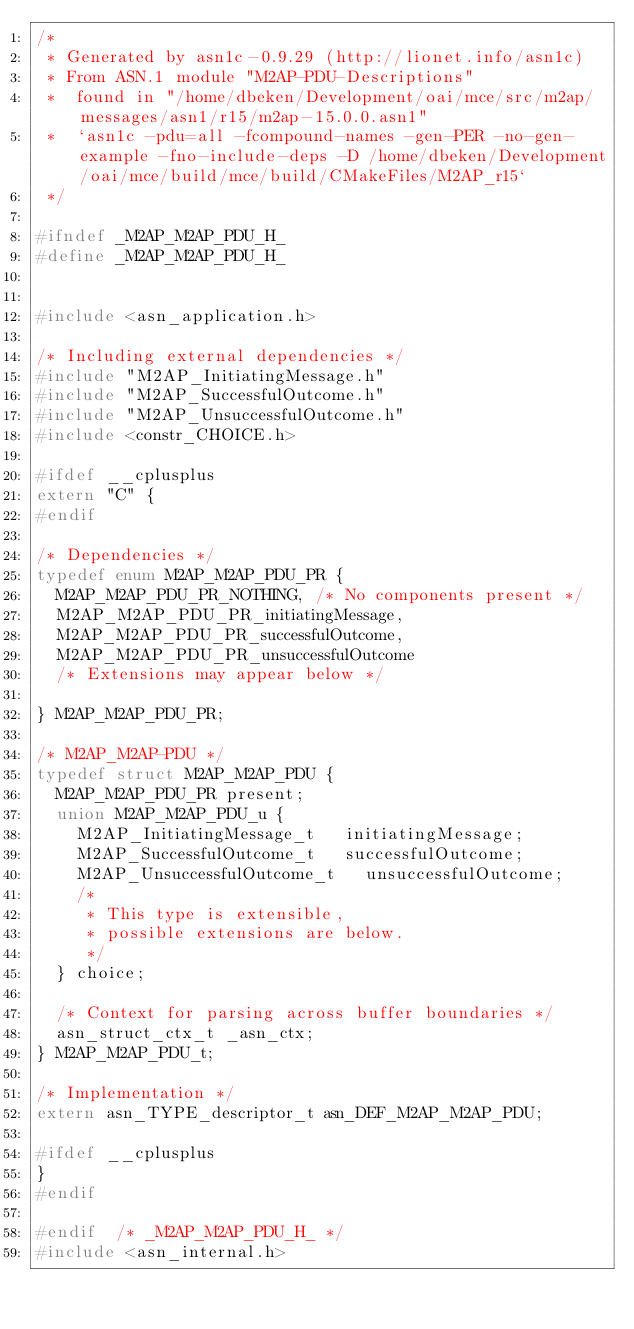Convert code to text. <code><loc_0><loc_0><loc_500><loc_500><_C_>/*
 * Generated by asn1c-0.9.29 (http://lionet.info/asn1c)
 * From ASN.1 module "M2AP-PDU-Descriptions"
 * 	found in "/home/dbeken/Development/oai/mce/src/m2ap/messages/asn1/r15/m2ap-15.0.0.asn1"
 * 	`asn1c -pdu=all -fcompound-names -gen-PER -no-gen-example -fno-include-deps -D /home/dbeken/Development/oai/mce/build/mce/build/CMakeFiles/M2AP_r15`
 */

#ifndef	_M2AP_M2AP_PDU_H_
#define	_M2AP_M2AP_PDU_H_


#include <asn_application.h>

/* Including external dependencies */
#include "M2AP_InitiatingMessage.h"
#include "M2AP_SuccessfulOutcome.h"
#include "M2AP_UnsuccessfulOutcome.h"
#include <constr_CHOICE.h>

#ifdef __cplusplus
extern "C" {
#endif

/* Dependencies */
typedef enum M2AP_M2AP_PDU_PR {
	M2AP_M2AP_PDU_PR_NOTHING,	/* No components present */
	M2AP_M2AP_PDU_PR_initiatingMessage,
	M2AP_M2AP_PDU_PR_successfulOutcome,
	M2AP_M2AP_PDU_PR_unsuccessfulOutcome
	/* Extensions may appear below */
	
} M2AP_M2AP_PDU_PR;

/* M2AP_M2AP-PDU */
typedef struct M2AP_M2AP_PDU {
	M2AP_M2AP_PDU_PR present;
	union M2AP_M2AP_PDU_u {
		M2AP_InitiatingMessage_t	 initiatingMessage;
		M2AP_SuccessfulOutcome_t	 successfulOutcome;
		M2AP_UnsuccessfulOutcome_t	 unsuccessfulOutcome;
		/*
		 * This type is extensible,
		 * possible extensions are below.
		 */
	} choice;
	
	/* Context for parsing across buffer boundaries */
	asn_struct_ctx_t _asn_ctx;
} M2AP_M2AP_PDU_t;

/* Implementation */
extern asn_TYPE_descriptor_t asn_DEF_M2AP_M2AP_PDU;

#ifdef __cplusplus
}
#endif

#endif	/* _M2AP_M2AP_PDU_H_ */
#include <asn_internal.h>
</code> 